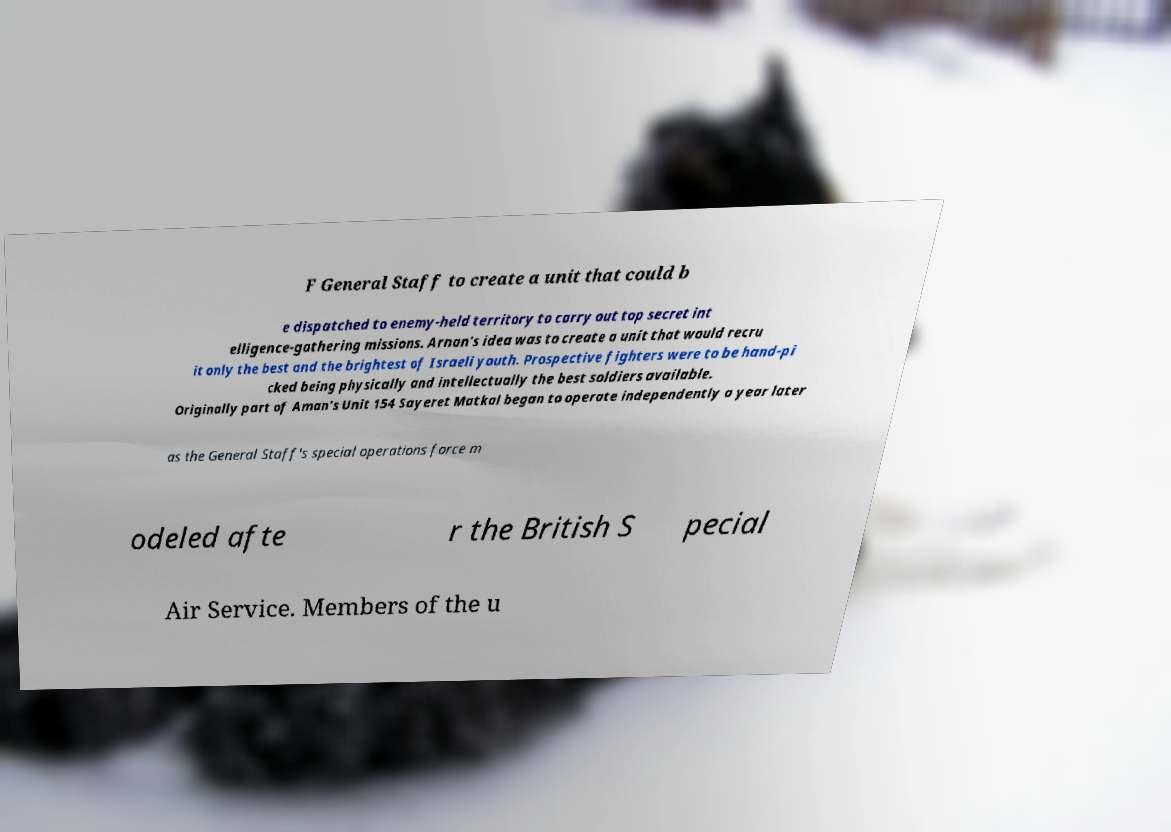Please identify and transcribe the text found in this image. F General Staff to create a unit that could b e dispatched to enemy-held territory to carry out top secret int elligence-gathering missions. Arnan's idea was to create a unit that would recru it only the best and the brightest of Israeli youth. Prospective fighters were to be hand-pi cked being physically and intellectually the best soldiers available. Originally part of Aman's Unit 154 Sayeret Matkal began to operate independently a year later as the General Staff's special operations force m odeled afte r the British S pecial Air Service. Members of the u 